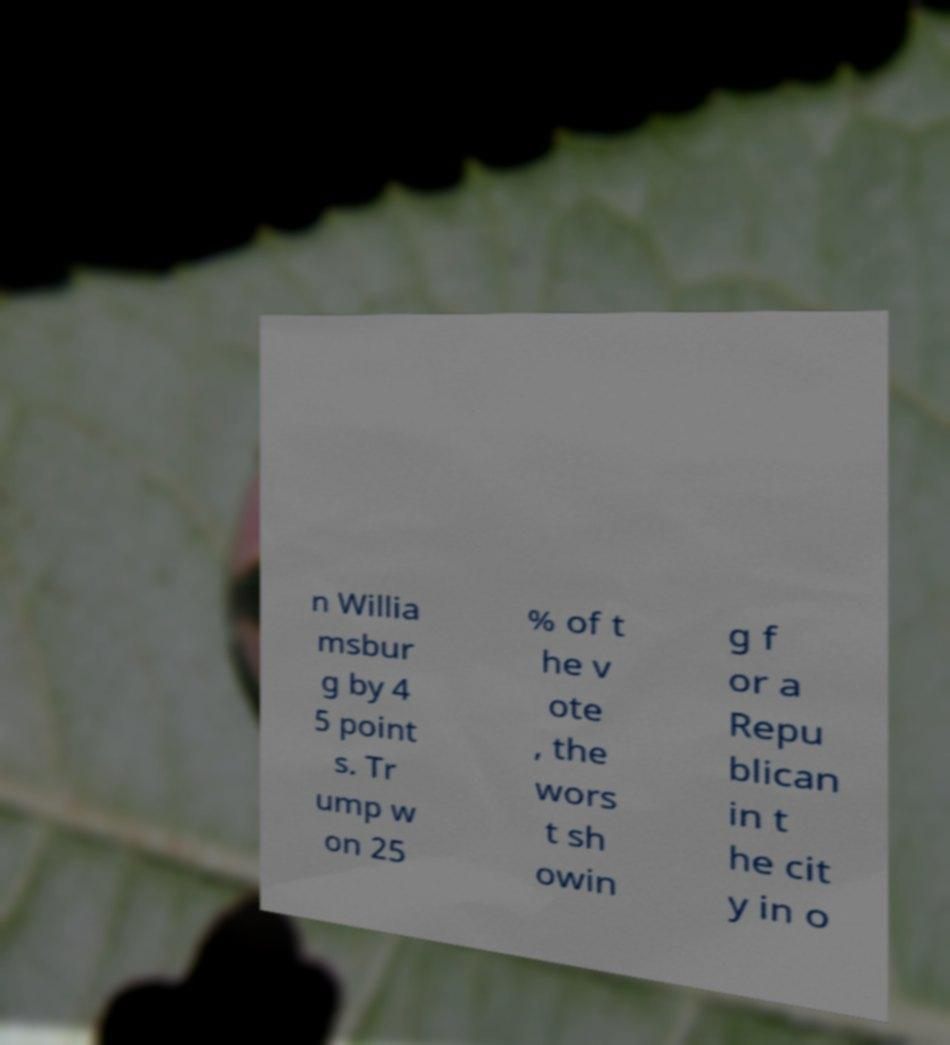Can you accurately transcribe the text from the provided image for me? n Willia msbur g by 4 5 point s. Tr ump w on 25 % of t he v ote , the wors t sh owin g f or a Repu blican in t he cit y in o 